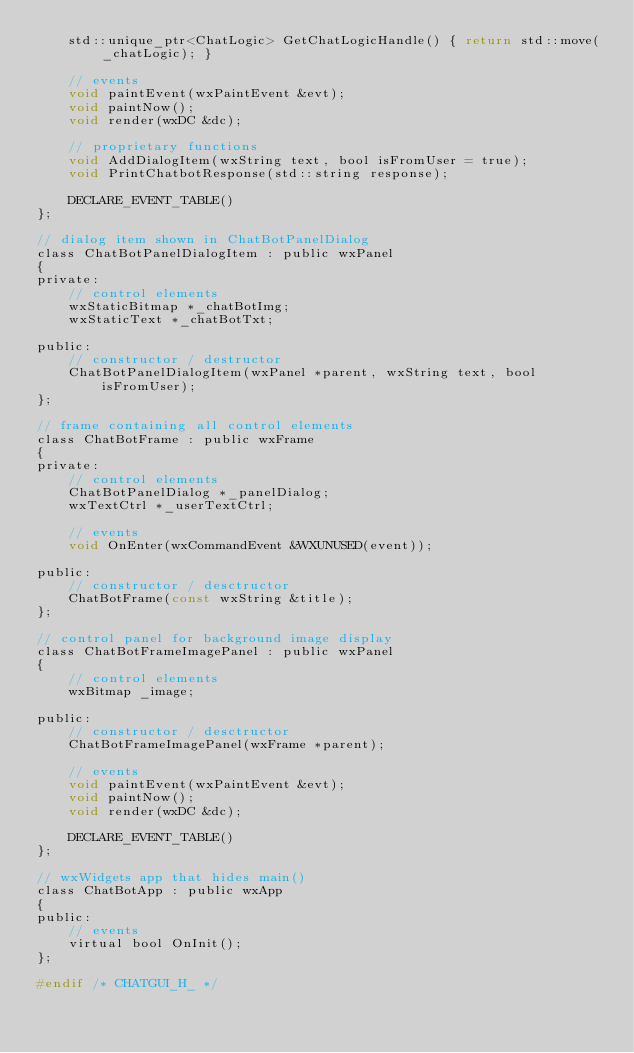<code> <loc_0><loc_0><loc_500><loc_500><_C_>    std::unique_ptr<ChatLogic> GetChatLogicHandle() { return std::move(_chatLogic); }

    // events
    void paintEvent(wxPaintEvent &evt);
    void paintNow();
    void render(wxDC &dc);

    // proprietary functions
    void AddDialogItem(wxString text, bool isFromUser = true);
    void PrintChatbotResponse(std::string response);

    DECLARE_EVENT_TABLE()
};

// dialog item shown in ChatBotPanelDialog
class ChatBotPanelDialogItem : public wxPanel
{
private:
    // control elements
    wxStaticBitmap *_chatBotImg;
    wxStaticText *_chatBotTxt;

public:
    // constructor / destructor
    ChatBotPanelDialogItem(wxPanel *parent, wxString text, bool isFromUser);
};

// frame containing all control elements
class ChatBotFrame : public wxFrame
{
private:
    // control elements
    ChatBotPanelDialog *_panelDialog;
    wxTextCtrl *_userTextCtrl;

    // events
    void OnEnter(wxCommandEvent &WXUNUSED(event));

public:
    // constructor / desctructor
    ChatBotFrame(const wxString &title);
};

// control panel for background image display
class ChatBotFrameImagePanel : public wxPanel
{
    // control elements
    wxBitmap _image;

public:
    // constructor / desctructor
    ChatBotFrameImagePanel(wxFrame *parent);

    // events
    void paintEvent(wxPaintEvent &evt);
    void paintNow();
    void render(wxDC &dc);

    DECLARE_EVENT_TABLE()
};

// wxWidgets app that hides main()
class ChatBotApp : public wxApp
{
public:
    // events
    virtual bool OnInit();
};

#endif /* CHATGUI_H_ */
</code> 